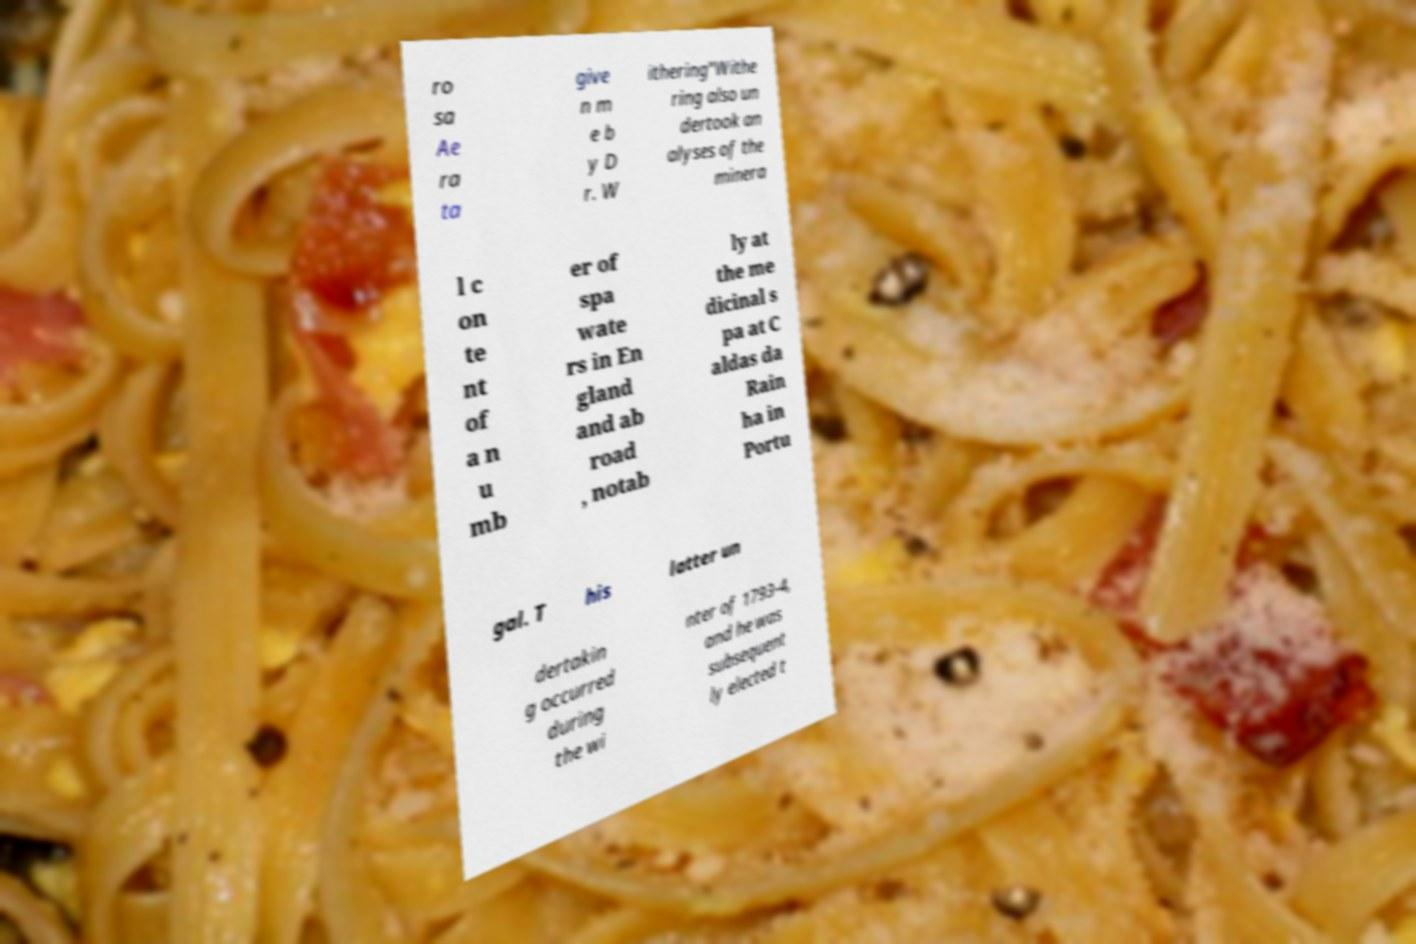Please read and relay the text visible in this image. What does it say? ro sa Ae ra ta give n m e b y D r. W ithering"Withe ring also un dertook an alyses of the minera l c on te nt of a n u mb er of spa wate rs in En gland and ab road , notab ly at the me dicinal s pa at C aldas da Rain ha in Portu gal. T his latter un dertakin g occurred during the wi nter of 1793-4, and he was subsequent ly elected t 